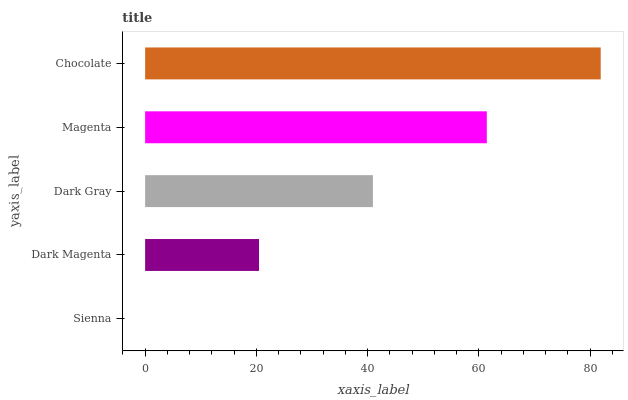Is Sienna the minimum?
Answer yes or no. Yes. Is Chocolate the maximum?
Answer yes or no. Yes. Is Dark Magenta the minimum?
Answer yes or no. No. Is Dark Magenta the maximum?
Answer yes or no. No. Is Dark Magenta greater than Sienna?
Answer yes or no. Yes. Is Sienna less than Dark Magenta?
Answer yes or no. Yes. Is Sienna greater than Dark Magenta?
Answer yes or no. No. Is Dark Magenta less than Sienna?
Answer yes or no. No. Is Dark Gray the high median?
Answer yes or no. Yes. Is Dark Gray the low median?
Answer yes or no. Yes. Is Dark Magenta the high median?
Answer yes or no. No. Is Sienna the low median?
Answer yes or no. No. 